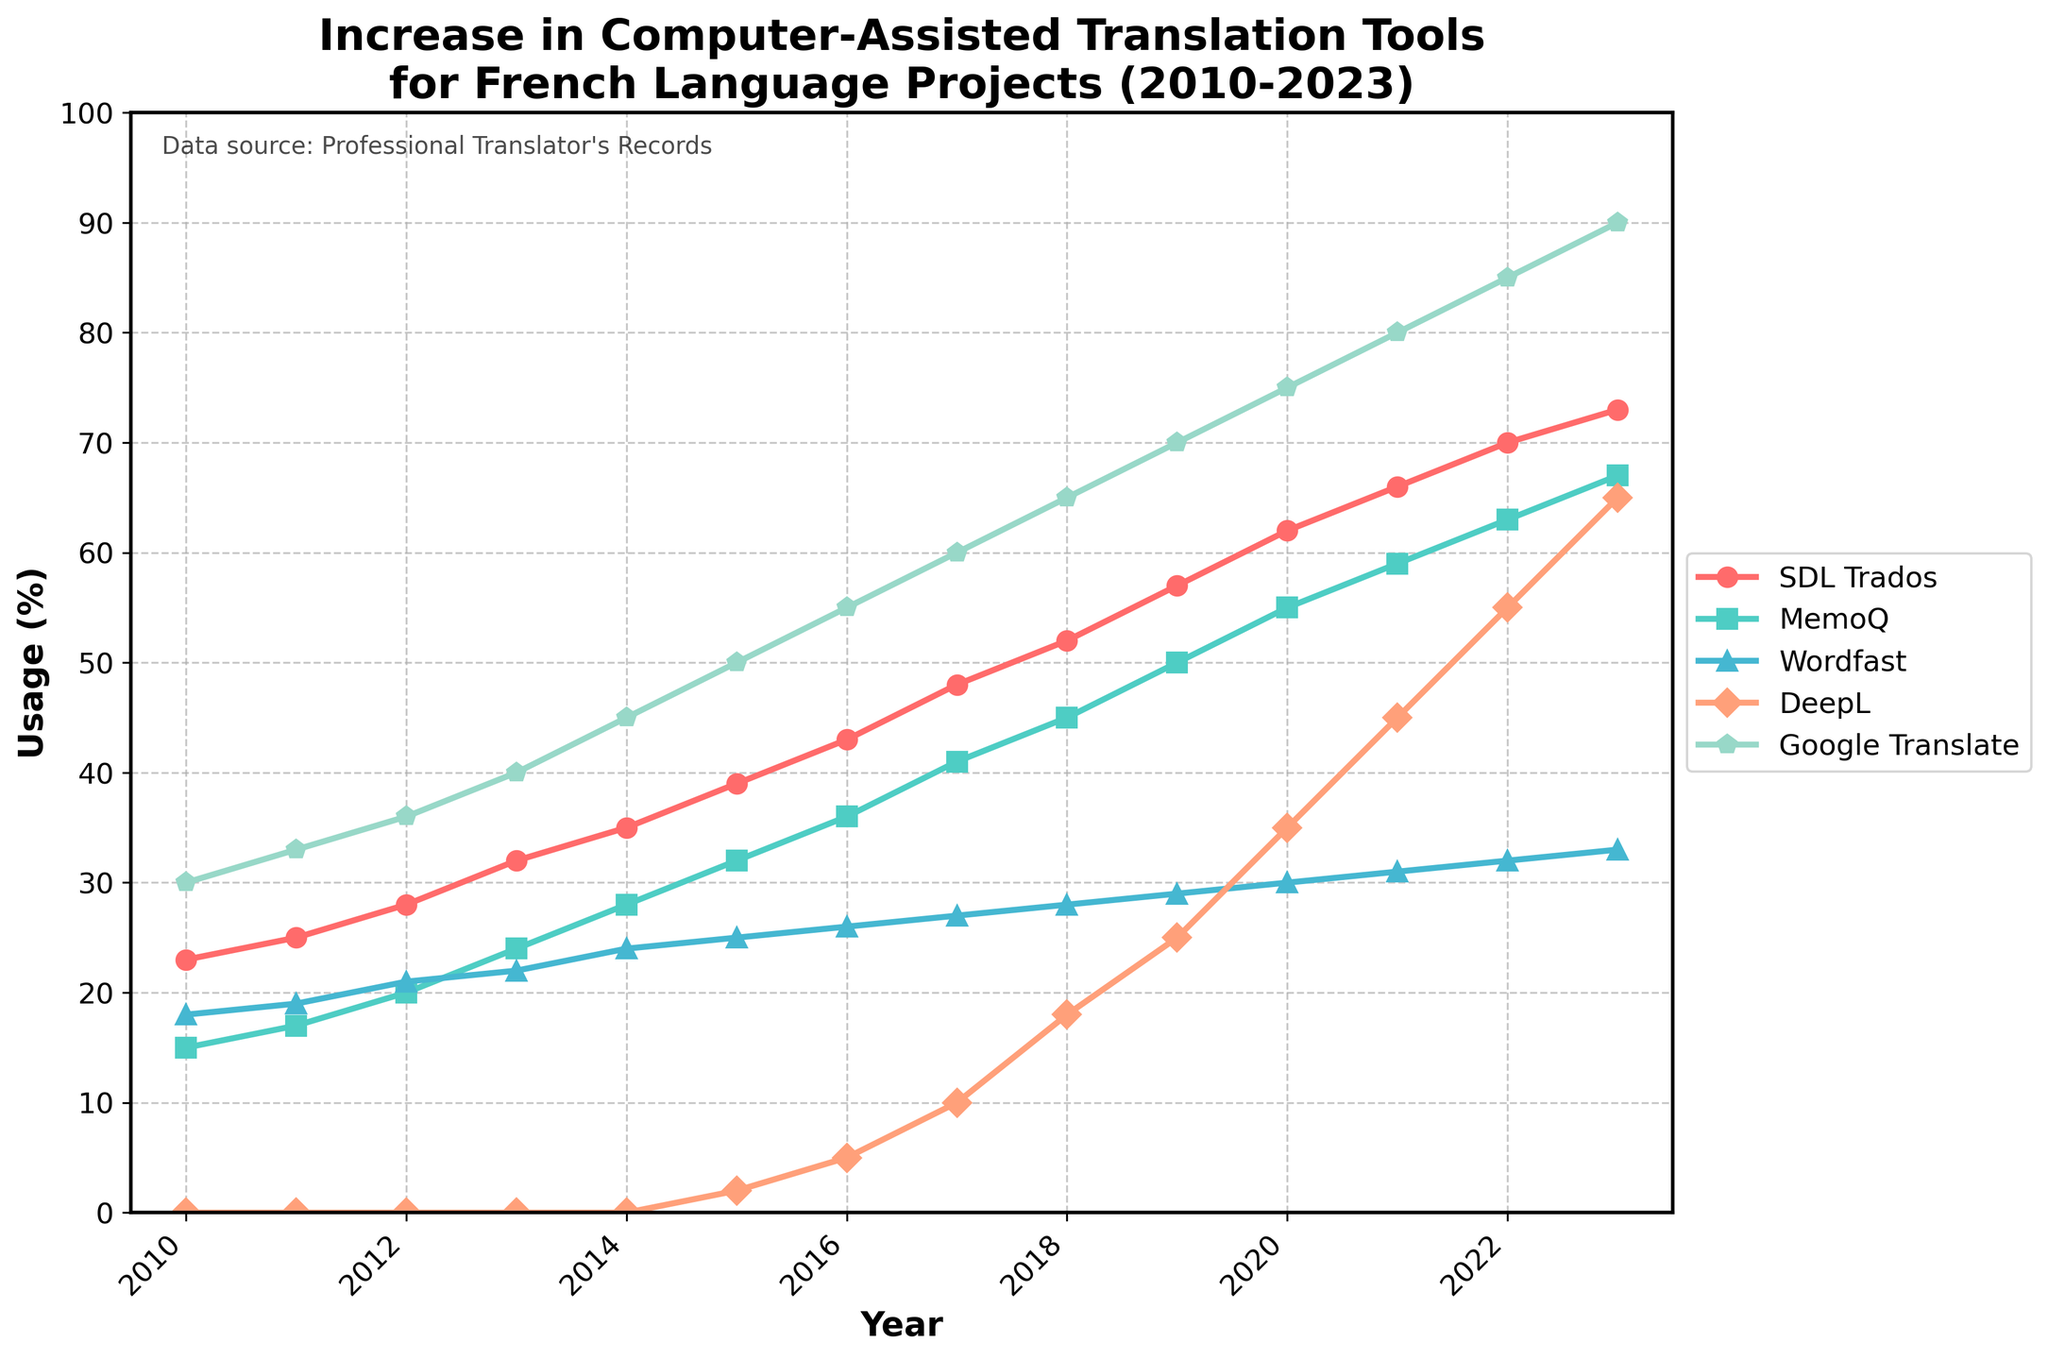What's the overall trend in the usage of SDL Trados from 2010 to 2023? The line chart shows that the usage of SDL Trados has a continuous upward trend from 2010 to 2023, starting at 23% in 2010 and increasing to 73% in 2023.
Answer: Increasing In which year did DeepL begin to be used in French language projects according to the chart? Observing the lines on the chart, DeepL's usage begins to appear in 2015 at 2%.
Answer: 2015 How does the usage of Google Translate in 2023 compare to its usage in 2010? In 2023, Google Translate's usage is at 90%, whereas, in 2010, it was 30%. Hence, there is an increase of 60 percentage points over the period.
Answer: 60 percentage points increase Between MemoQ and Wordfast, which tool had a higher usage in 2015, and by how much? In 2015, MemoQ's usage was 32%, while Wordfast was 25%. The difference in their usage is 7 percentage points.
Answer: MemoQ by 7 percentage points What is the average yearly increase in the usage of SDL Trados from 2010 to 2023? To find the average yearly increase, subtract the usage in 2010 (23%) from the usage in 2023 (73%), then divide by the number of years (20-10 + 1) = 13 years. (73% - 23%) / 13 = 50% / 13 ≈ 3.85% per year.
Answer: 3.85% per year Which translation tool showed the most significant increase in usage over this period, and what was the increase? Compare the usage increase for all tools from 2010 to 2023. DeepL increased from 0% to 65%, a 65 percentage points increase, which is the most significant among all tools.
Answer: DeepL, 65 percentage points Does the data show that the usage of Wordfast is increasing or decreasing from 2010 to 2023? By analyzing the Wordfast line on the chart, it shows a gradual but steady increase from 18% in 2010 to 33% in 2023.
Answer: Increasing Calculate the median usage value of MemoQ from 2010 to 2023. List the MemoQ values: [15, 17, 20, 24, 28, 32, 36, 41, 45, 50, 55, 59, 63, 67]. Since there are 14 data points, the median would be the average of the 7th and 8th values. (36 + 41) / 2 = 38.5
Answer: 38.5 Between 2018 and 2023, which tool had the highest rate of increase in usage, and what was that rate? Calculate the rate of increase for each tool from 2018 to 2023. For DeepL: (65% - 18%) / 5 = 47% / 5 = 9.4% per year, which is the highest.
Answer: DeepL, 9.4% per year 